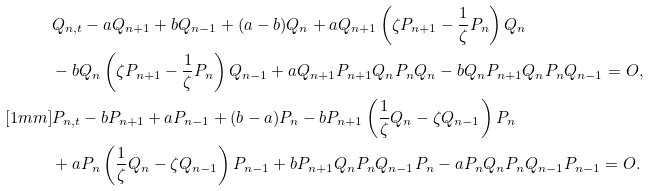<formula> <loc_0><loc_0><loc_500><loc_500>& Q _ { n , t } - a Q _ { n + 1 } + b Q _ { n - 1 } + ( a - b ) Q _ { n } + a Q _ { n + 1 } \left ( \zeta P _ { n + 1 } - \frac { 1 } { \zeta } P _ { n } \right ) Q _ { n } \\ & - b Q _ { n } \left ( \zeta P _ { n + 1 } - \frac { 1 } { \zeta } P _ { n } \right ) Q _ { n - 1 } + a Q _ { n + 1 } P _ { n + 1 } Q _ { n } P _ { n } Q _ { n } - b Q _ { n } P _ { n + 1 } Q _ { n } P _ { n } Q _ { n - 1 } = O , \\ [ 1 m m ] & P _ { n , t } - b P _ { n + 1 } + a P _ { n - 1 } + ( b - a ) P _ { n } - b P _ { n + 1 } \left ( \frac { 1 } { \zeta } Q _ { n } - \zeta Q _ { n - 1 } \right ) P _ { n } \\ & + a P _ { n } \left ( \frac { 1 } { \zeta } Q _ { n } - \zeta Q _ { n - 1 } \right ) P _ { n - 1 } + b P _ { n + 1 } Q _ { n } P _ { n } Q _ { n - 1 } P _ { n } - a P _ { n } Q _ { n } P _ { n } Q _ { n - 1 } P _ { n - 1 } = O .</formula> 